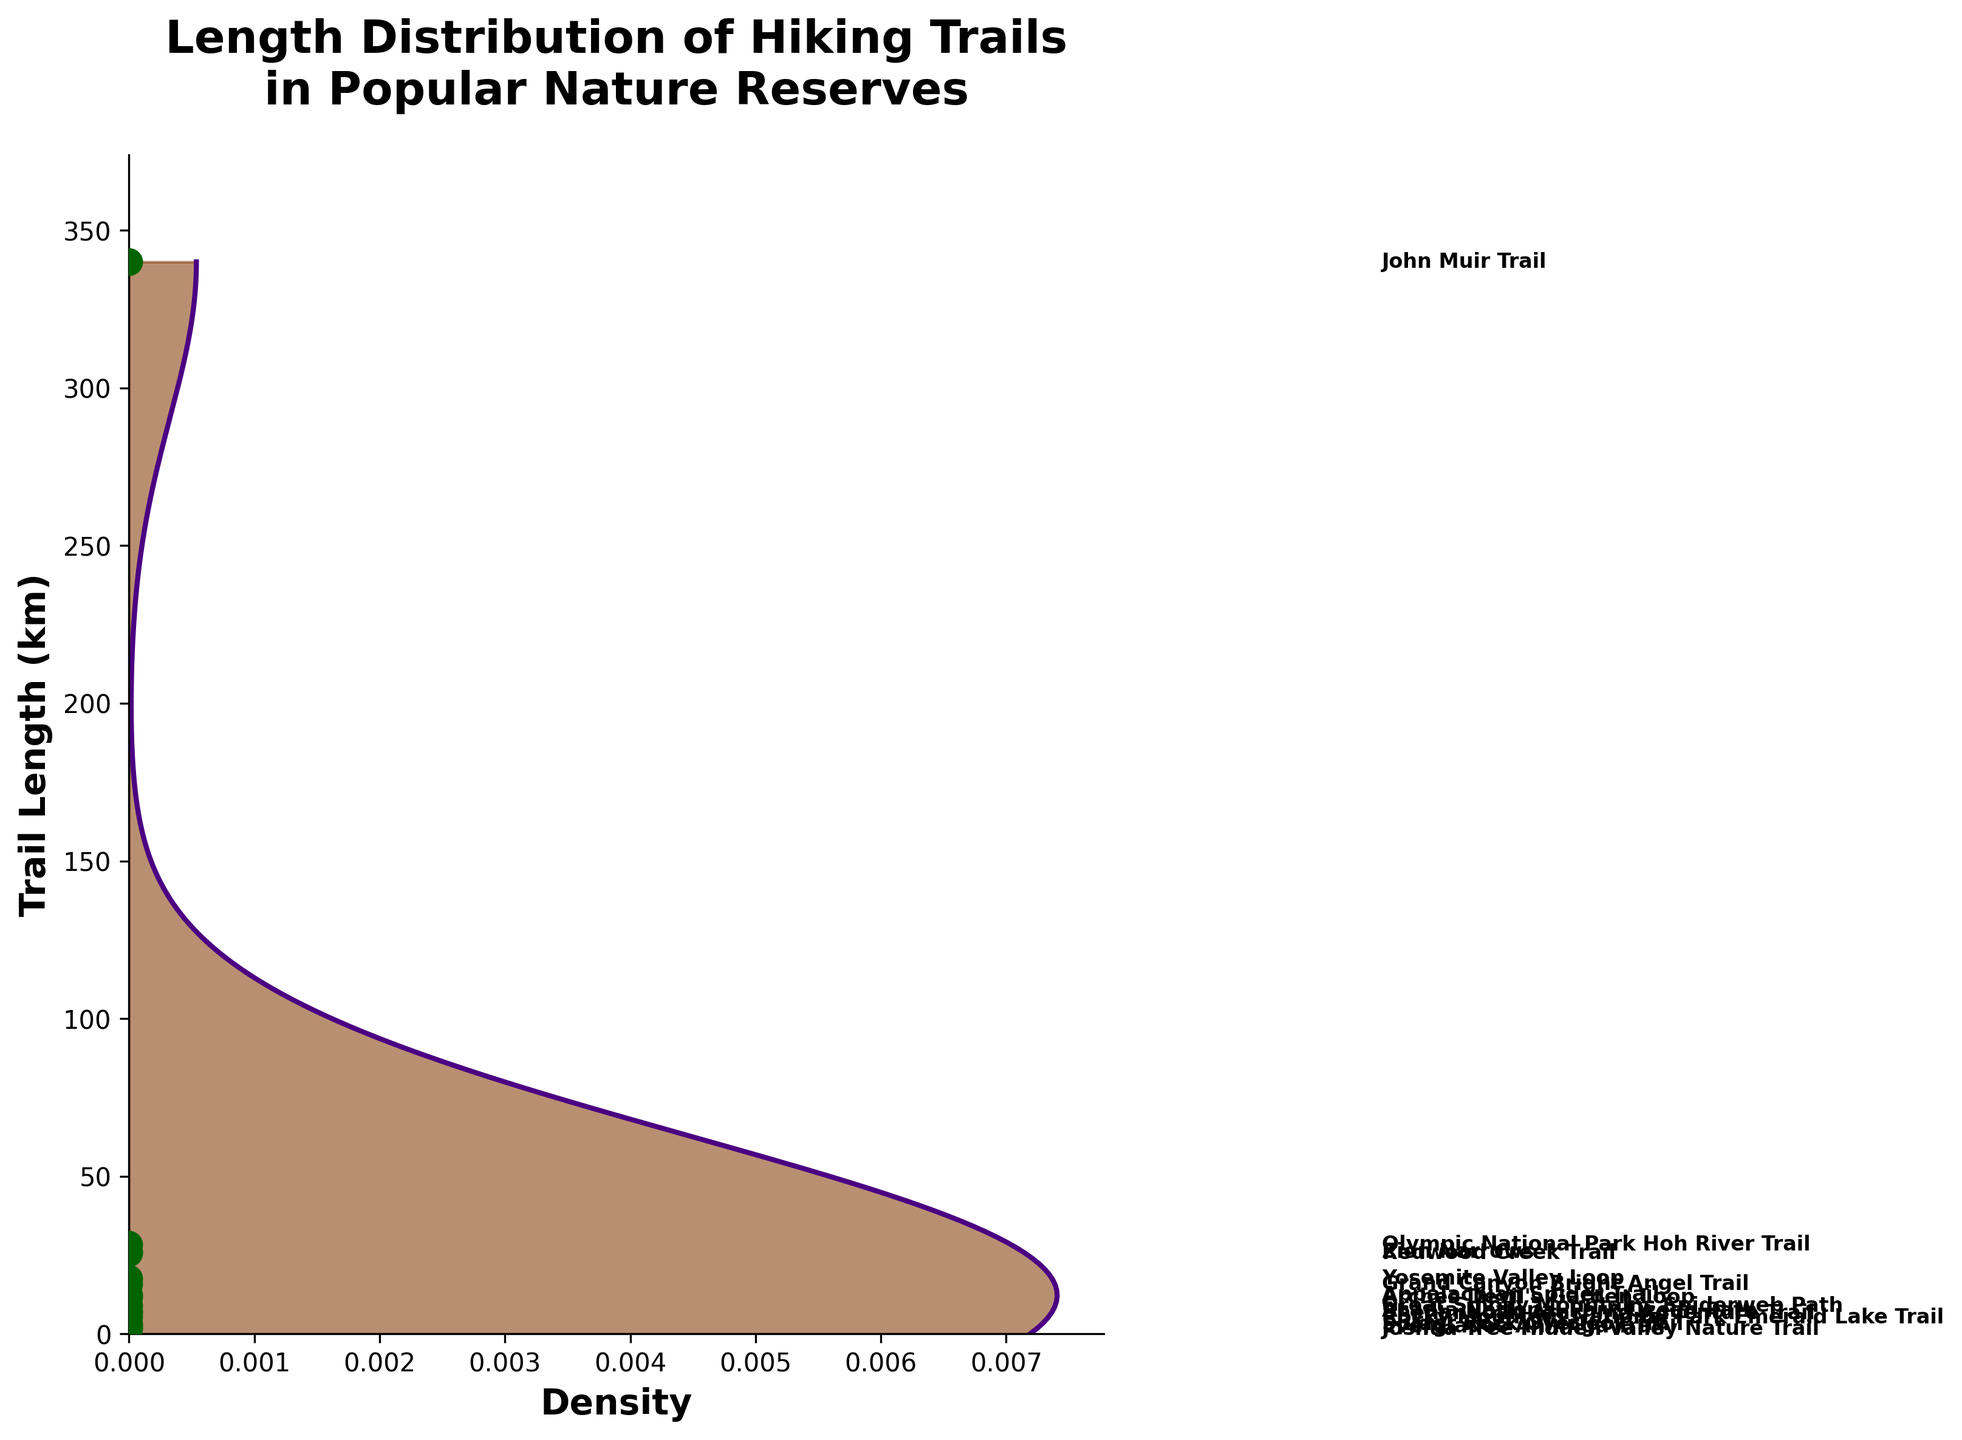What is the title of the figure? The title can be found at the top of the figure in larger and bold text. It provides a summary of what the figure represents.
Answer: Length Distribution of Hiking Trails in Popular Nature Reserves What is the range of trail lengths shown on the Y-axis? The range is determined by the minimum and maximum values indicated on the Y-axis, which is labeled 'Trail Length (km)'. The range starts from 0 and extends slightly beyond the longest trail length to ensure all data points are visible.
Answer: 0 to approximately 374 km Which data point represents the shortest trail, and what is its length? The shortest trail can be identified by the lowest scatter point on the Y-axis. The name of the trail is usually labeled next to the point, and its position on the Y-axis indicates the length.
Answer: Joshua Tree Hidden Valley Nature Trail, 1.6 km Which trail has the longest length, and how long is it? The highest data point on the Y-axis represents the longest trail. The name of the trail is labeled adjacent to this point, indicating its length.
Answer: John Muir Trail, 340.0 km How many trails are shorter than 10 km? To answer this, count the number of scatter points positioned below the 10 km mark on the Y-axis. Each point corresponds to a trail.
Answer: 6 trails Which spider-themed trail is the longest, and what is its length? Look for trails with names related to spiders and identify the one with the highest position among them on the Y-axis.
Answer: Appalachian Spider Trail, 12.3 km Compare the lengths of 'Yosemite Valley Loop' and 'Grand Canyon Bright Angel Trail'. Which one is longer and by how much? Find the positions of these two trails on the Y-axis. Subtract the length of the 'Grand Canyon Bright Angel Trail' from the 'Yosemite Valley Loop' to determine the difference.
Answer: Yosemite Valley Loop is longer by 1.7 km What is the median trail length in the figure? To find the median, arrange the lengths of all trails in ascending order and identify the middle value. If there is an odd number of trails, it is the middle one; if even, calculate the average of the two middle values.
Answer: Approximately 11.6 km Describe the distribution shape of trail lengths. Analyze the density plot, which indicates how trail lengths are spread out. The height and width of the shaded areas show the concentration of trail lengths at different values. The distribution's shape suggests the most common trail lengths and the presence of any skewness.
Answer: Positively skewed, with more trails having shorter lengths Is there any visual enhancement specific to the figure type that makes it unique? Check the figure for any additional aesthetic elements or decorations that enhance the visual appeal or thematic connection, beyond the standard density plot and scatter points.
Answer: Yes, a spider web decoration is added, indicating the nature enthusiast and spider lover theme 